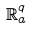Convert formula to latex. <formula><loc_0><loc_0><loc_500><loc_500>\mathbb { R } _ { a } ^ { q }</formula> 